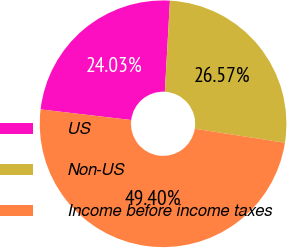<chart> <loc_0><loc_0><loc_500><loc_500><pie_chart><fcel>US<fcel>Non-US<fcel>Income before income taxes<nl><fcel>24.03%<fcel>26.57%<fcel>49.4%<nl></chart> 